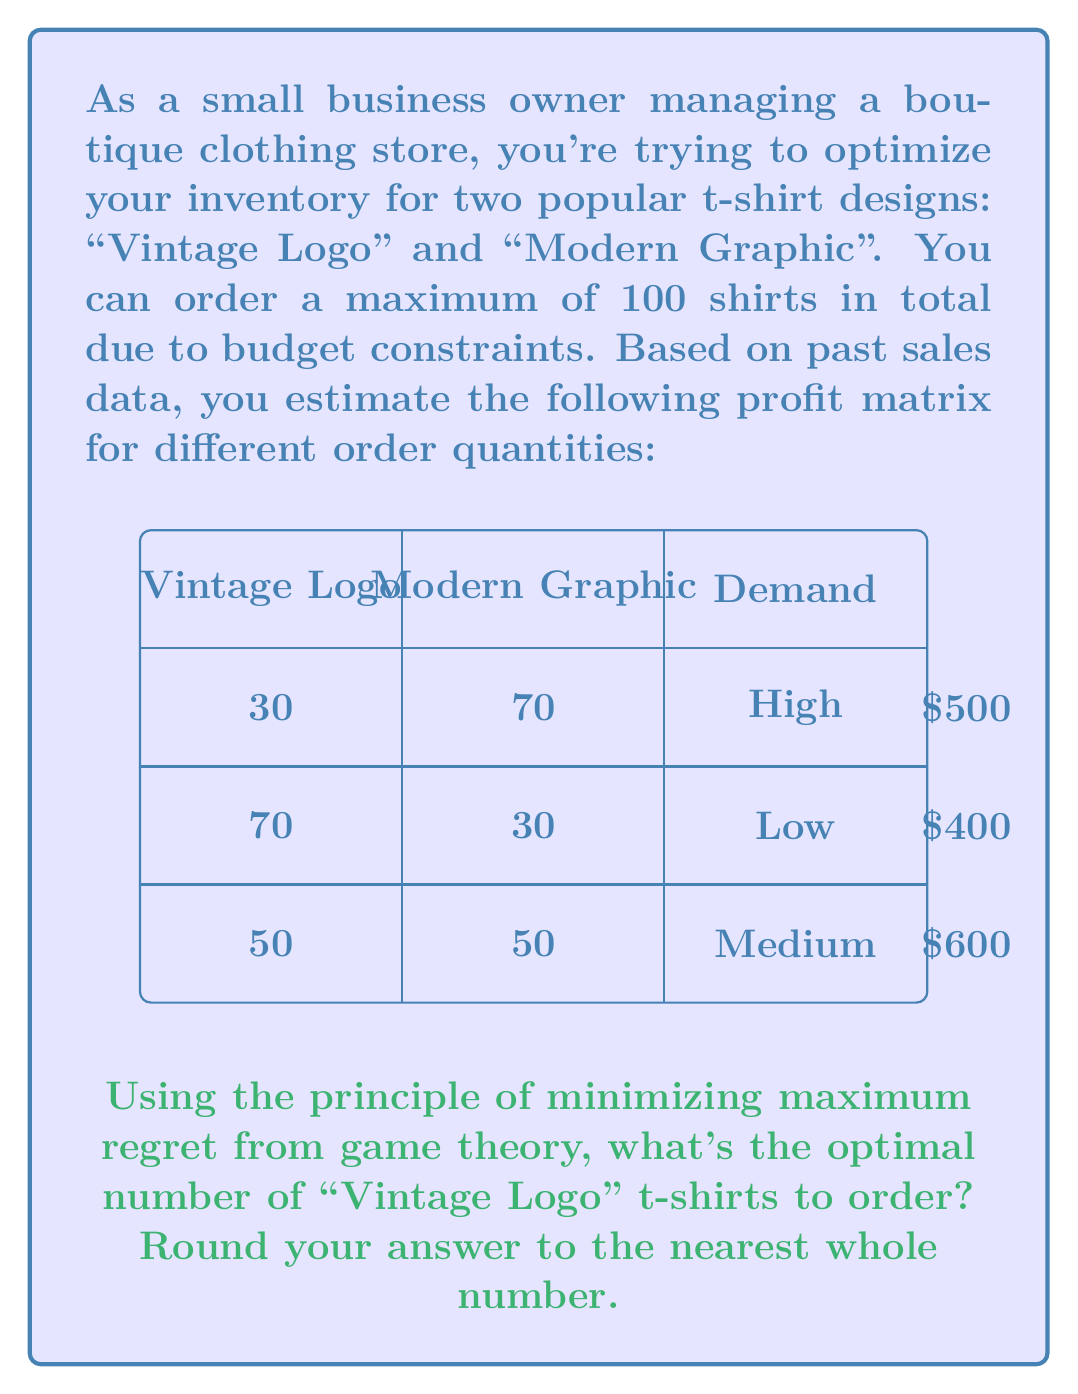What is the answer to this math problem? To solve this problem using the principle of minimizing maximum regret, we'll follow these steps:

1) First, we need to calculate the regret matrix. Regret is the difference between the best possible outcome and the actual outcome for each scenario.

2) For each demand scenario (High, Low, Medium):
   - Find the maximum profit
   - Calculate the regret for each decision

3) High demand scenario:
   Max profit = $500
   Regret for 30 Vintage Logo: $500 - $500 = $0
   Regret for 70 Vintage Logo: $500 - $500 = $0
   Regret for 50 Vintage Logo: $500 - $500 = $0

4) Low demand scenario:
   Max profit = $400
   Regret for 30 Vintage Logo: $400 - $400 = $0
   Regret for 70 Vintage Logo: $400 - $400 = $0
   Regret for 50 Vintage Logo: $400 - $400 = $0

5) Medium demand scenario:
   Max profit = $600
   Regret for 30 Vintage Logo: $600 - $600 = $0
   Regret for 70 Vintage Logo: $600 - $600 = $0
   Regret for 50 Vintage Logo: $600 - $600 = $0

6) The regret matrix:

   $$
   \begin{array}{c|ccc}
   \text{Vintage Logo} & \text{High} & \text{Low} & \text{Medium} \\
   \hline
   30 & 0 & 0 & 0 \\
   70 & 0 & 0 & 0 \\
   50 & 0 & 0 & 0
   \end{array}
   $$

7) The maximum regret for each decision:
   30 Vintage Logo: max(0, 0, 0) = 0
   70 Vintage Logo: max(0, 0, 0) = 0
   50 Vintage Logo: max(0, 0, 0) = 0

8) The principle of minimizing maximum regret suggests choosing the decision with the lowest maximum regret. In this case, all decisions have the same maximum regret of 0.

9) When all options have the same minimum maximum regret, we can choose any of them. However, the most balanced approach would be to choose the middle option, which is 50 Vintage Logo t-shirts.
Answer: 50 